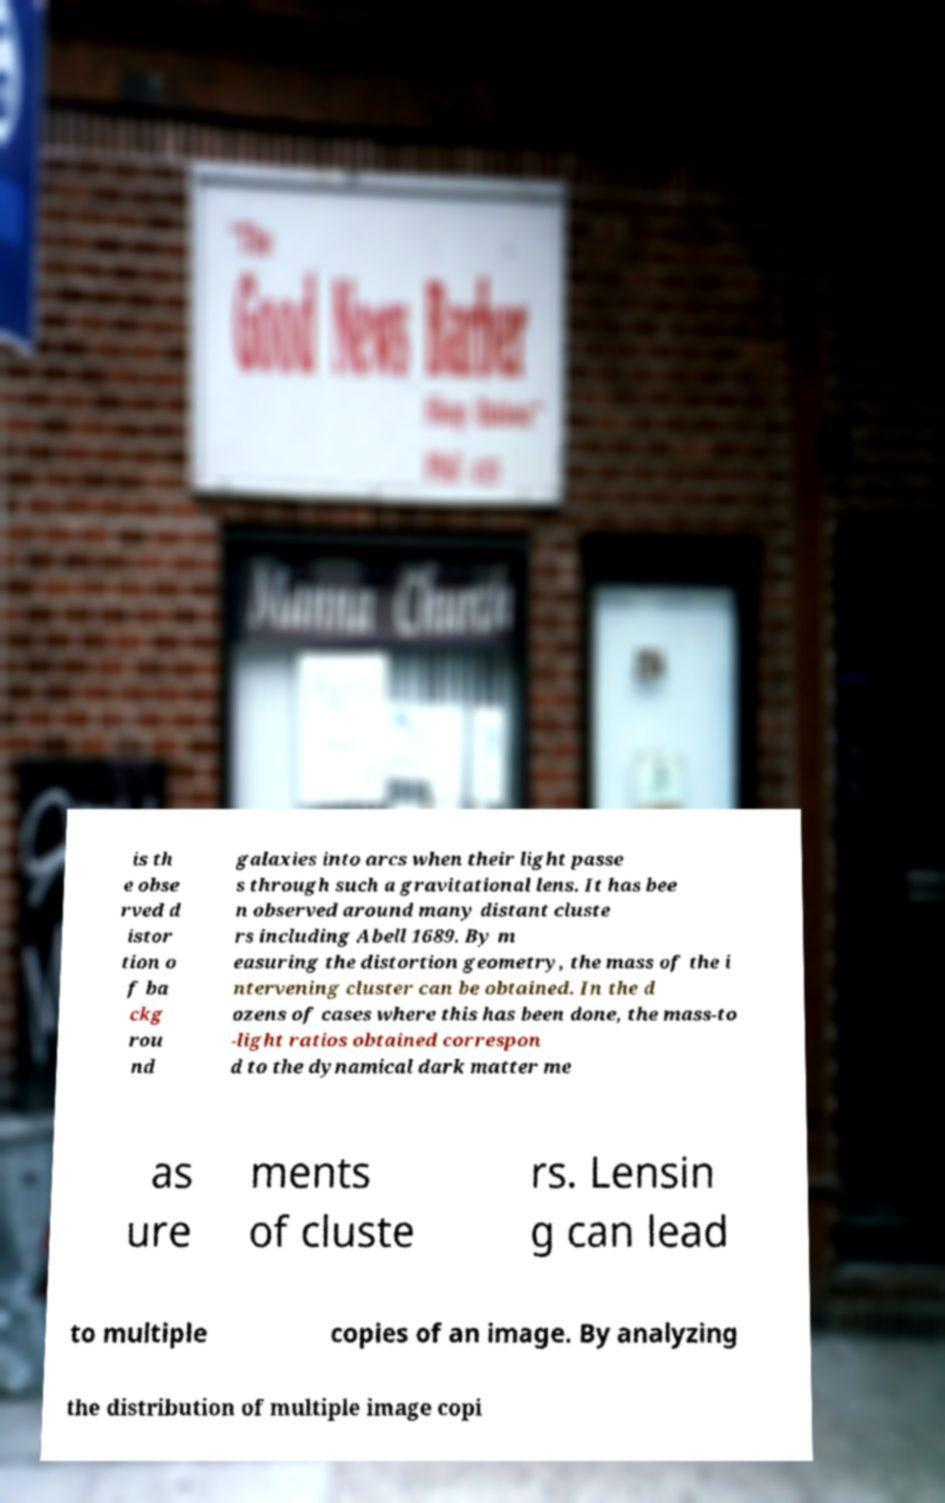Could you extract and type out the text from this image? is th e obse rved d istor tion o f ba ckg rou nd galaxies into arcs when their light passe s through such a gravitational lens. It has bee n observed around many distant cluste rs including Abell 1689. By m easuring the distortion geometry, the mass of the i ntervening cluster can be obtained. In the d ozens of cases where this has been done, the mass-to -light ratios obtained correspon d to the dynamical dark matter me as ure ments of cluste rs. Lensin g can lead to multiple copies of an image. By analyzing the distribution of multiple image copi 